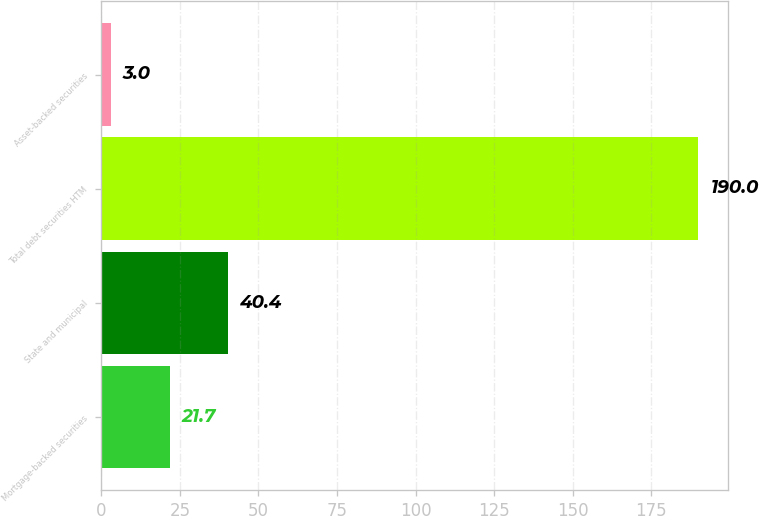<chart> <loc_0><loc_0><loc_500><loc_500><bar_chart><fcel>Mortgage-backed securities<fcel>State and municipal<fcel>Total debt securities HTM<fcel>Asset-backed securities<nl><fcel>21.7<fcel>40.4<fcel>190<fcel>3<nl></chart> 